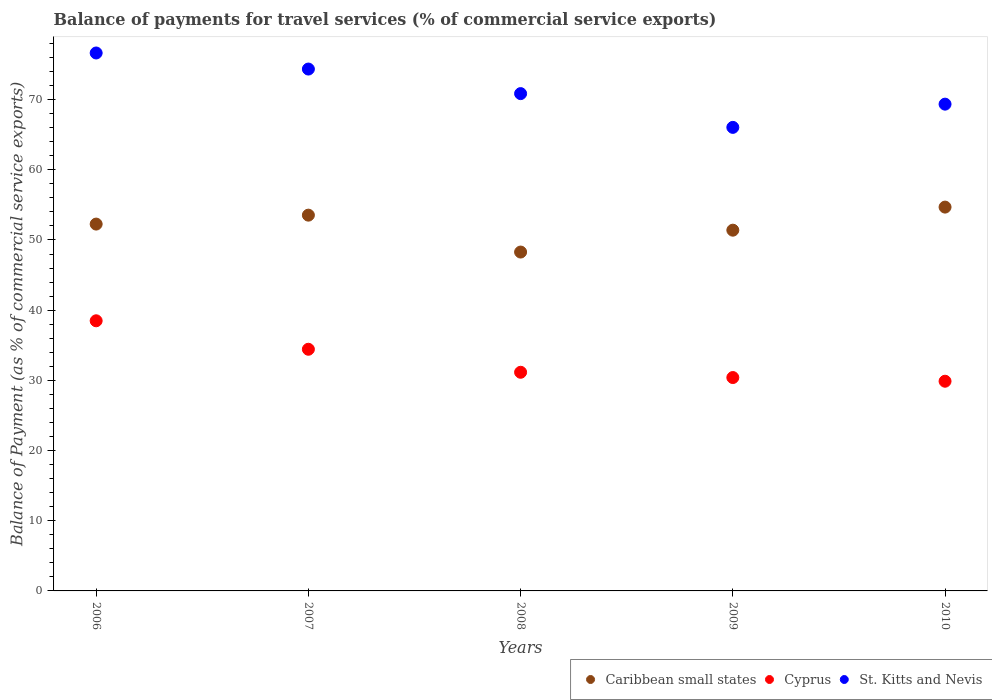What is the balance of payments for travel services in St. Kitts and Nevis in 2007?
Keep it short and to the point. 74.35. Across all years, what is the maximum balance of payments for travel services in Cyprus?
Provide a short and direct response. 38.49. Across all years, what is the minimum balance of payments for travel services in St. Kitts and Nevis?
Your answer should be very brief. 66.05. In which year was the balance of payments for travel services in Cyprus maximum?
Offer a terse response. 2006. In which year was the balance of payments for travel services in Cyprus minimum?
Keep it short and to the point. 2010. What is the total balance of payments for travel services in St. Kitts and Nevis in the graph?
Give a very brief answer. 357.26. What is the difference between the balance of payments for travel services in Cyprus in 2007 and that in 2010?
Give a very brief answer. 4.55. What is the difference between the balance of payments for travel services in Caribbean small states in 2006 and the balance of payments for travel services in Cyprus in 2010?
Your answer should be compact. 22.39. What is the average balance of payments for travel services in Caribbean small states per year?
Make the answer very short. 52.03. In the year 2010, what is the difference between the balance of payments for travel services in St. Kitts and Nevis and balance of payments for travel services in Caribbean small states?
Your answer should be very brief. 14.67. What is the ratio of the balance of payments for travel services in St. Kitts and Nevis in 2006 to that in 2010?
Your answer should be compact. 1.11. Is the balance of payments for travel services in Caribbean small states in 2006 less than that in 2009?
Give a very brief answer. No. Is the difference between the balance of payments for travel services in St. Kitts and Nevis in 2009 and 2010 greater than the difference between the balance of payments for travel services in Caribbean small states in 2009 and 2010?
Your response must be concise. No. What is the difference between the highest and the second highest balance of payments for travel services in Caribbean small states?
Ensure brevity in your answer.  1.15. What is the difference between the highest and the lowest balance of payments for travel services in St. Kitts and Nevis?
Offer a terse response. 10.6. Is the sum of the balance of payments for travel services in St. Kitts and Nevis in 2006 and 2010 greater than the maximum balance of payments for travel services in Caribbean small states across all years?
Offer a very short reply. Yes. Is it the case that in every year, the sum of the balance of payments for travel services in Cyprus and balance of payments for travel services in Caribbean small states  is greater than the balance of payments for travel services in St. Kitts and Nevis?
Your response must be concise. Yes. Is the balance of payments for travel services in Caribbean small states strictly greater than the balance of payments for travel services in Cyprus over the years?
Offer a very short reply. Yes. Is the balance of payments for travel services in Caribbean small states strictly less than the balance of payments for travel services in St. Kitts and Nevis over the years?
Keep it short and to the point. Yes. How many dotlines are there?
Your response must be concise. 3. How many years are there in the graph?
Provide a short and direct response. 5. What is the difference between two consecutive major ticks on the Y-axis?
Your response must be concise. 10. Does the graph contain any zero values?
Give a very brief answer. No. Where does the legend appear in the graph?
Your response must be concise. Bottom right. How many legend labels are there?
Offer a very short reply. 3. What is the title of the graph?
Your answer should be very brief. Balance of payments for travel services (% of commercial service exports). Does "Palau" appear as one of the legend labels in the graph?
Offer a terse response. No. What is the label or title of the Y-axis?
Your answer should be very brief. Balance of Payment (as % of commercial service exports). What is the Balance of Payment (as % of commercial service exports) in Caribbean small states in 2006?
Your response must be concise. 52.27. What is the Balance of Payment (as % of commercial service exports) in Cyprus in 2006?
Keep it short and to the point. 38.49. What is the Balance of Payment (as % of commercial service exports) in St. Kitts and Nevis in 2006?
Provide a short and direct response. 76.64. What is the Balance of Payment (as % of commercial service exports) in Caribbean small states in 2007?
Ensure brevity in your answer.  53.54. What is the Balance of Payment (as % of commercial service exports) of Cyprus in 2007?
Your response must be concise. 34.43. What is the Balance of Payment (as % of commercial service exports) of St. Kitts and Nevis in 2007?
Offer a terse response. 74.35. What is the Balance of Payment (as % of commercial service exports) of Caribbean small states in 2008?
Provide a succinct answer. 48.28. What is the Balance of Payment (as % of commercial service exports) in Cyprus in 2008?
Offer a terse response. 31.15. What is the Balance of Payment (as % of commercial service exports) in St. Kitts and Nevis in 2008?
Your response must be concise. 70.86. What is the Balance of Payment (as % of commercial service exports) in Caribbean small states in 2009?
Your response must be concise. 51.4. What is the Balance of Payment (as % of commercial service exports) in Cyprus in 2009?
Provide a short and direct response. 30.4. What is the Balance of Payment (as % of commercial service exports) in St. Kitts and Nevis in 2009?
Your response must be concise. 66.05. What is the Balance of Payment (as % of commercial service exports) of Caribbean small states in 2010?
Your answer should be very brief. 54.69. What is the Balance of Payment (as % of commercial service exports) of Cyprus in 2010?
Your answer should be very brief. 29.88. What is the Balance of Payment (as % of commercial service exports) of St. Kitts and Nevis in 2010?
Your answer should be compact. 69.36. Across all years, what is the maximum Balance of Payment (as % of commercial service exports) in Caribbean small states?
Provide a short and direct response. 54.69. Across all years, what is the maximum Balance of Payment (as % of commercial service exports) in Cyprus?
Keep it short and to the point. 38.49. Across all years, what is the maximum Balance of Payment (as % of commercial service exports) of St. Kitts and Nevis?
Your answer should be very brief. 76.64. Across all years, what is the minimum Balance of Payment (as % of commercial service exports) in Caribbean small states?
Keep it short and to the point. 48.28. Across all years, what is the minimum Balance of Payment (as % of commercial service exports) in Cyprus?
Your response must be concise. 29.88. Across all years, what is the minimum Balance of Payment (as % of commercial service exports) of St. Kitts and Nevis?
Ensure brevity in your answer.  66.05. What is the total Balance of Payment (as % of commercial service exports) of Caribbean small states in the graph?
Keep it short and to the point. 260.17. What is the total Balance of Payment (as % of commercial service exports) in Cyprus in the graph?
Provide a succinct answer. 164.35. What is the total Balance of Payment (as % of commercial service exports) of St. Kitts and Nevis in the graph?
Ensure brevity in your answer.  357.26. What is the difference between the Balance of Payment (as % of commercial service exports) in Caribbean small states in 2006 and that in 2007?
Ensure brevity in your answer.  -1.27. What is the difference between the Balance of Payment (as % of commercial service exports) of Cyprus in 2006 and that in 2007?
Ensure brevity in your answer.  4.06. What is the difference between the Balance of Payment (as % of commercial service exports) in St. Kitts and Nevis in 2006 and that in 2007?
Ensure brevity in your answer.  2.29. What is the difference between the Balance of Payment (as % of commercial service exports) in Caribbean small states in 2006 and that in 2008?
Provide a succinct answer. 3.98. What is the difference between the Balance of Payment (as % of commercial service exports) in Cyprus in 2006 and that in 2008?
Offer a terse response. 7.34. What is the difference between the Balance of Payment (as % of commercial service exports) in St. Kitts and Nevis in 2006 and that in 2008?
Ensure brevity in your answer.  5.79. What is the difference between the Balance of Payment (as % of commercial service exports) of Caribbean small states in 2006 and that in 2009?
Provide a succinct answer. 0.87. What is the difference between the Balance of Payment (as % of commercial service exports) in Cyprus in 2006 and that in 2009?
Your answer should be very brief. 8.09. What is the difference between the Balance of Payment (as % of commercial service exports) in St. Kitts and Nevis in 2006 and that in 2009?
Offer a very short reply. 10.6. What is the difference between the Balance of Payment (as % of commercial service exports) in Caribbean small states in 2006 and that in 2010?
Offer a terse response. -2.42. What is the difference between the Balance of Payment (as % of commercial service exports) of Cyprus in 2006 and that in 2010?
Offer a very short reply. 8.61. What is the difference between the Balance of Payment (as % of commercial service exports) of St. Kitts and Nevis in 2006 and that in 2010?
Provide a short and direct response. 7.29. What is the difference between the Balance of Payment (as % of commercial service exports) in Caribbean small states in 2007 and that in 2008?
Ensure brevity in your answer.  5.26. What is the difference between the Balance of Payment (as % of commercial service exports) in Cyprus in 2007 and that in 2008?
Ensure brevity in your answer.  3.28. What is the difference between the Balance of Payment (as % of commercial service exports) in St. Kitts and Nevis in 2007 and that in 2008?
Offer a very short reply. 3.5. What is the difference between the Balance of Payment (as % of commercial service exports) of Caribbean small states in 2007 and that in 2009?
Offer a terse response. 2.14. What is the difference between the Balance of Payment (as % of commercial service exports) of Cyprus in 2007 and that in 2009?
Your response must be concise. 4.03. What is the difference between the Balance of Payment (as % of commercial service exports) in St. Kitts and Nevis in 2007 and that in 2009?
Offer a terse response. 8.31. What is the difference between the Balance of Payment (as % of commercial service exports) in Caribbean small states in 2007 and that in 2010?
Give a very brief answer. -1.15. What is the difference between the Balance of Payment (as % of commercial service exports) in Cyprus in 2007 and that in 2010?
Your response must be concise. 4.55. What is the difference between the Balance of Payment (as % of commercial service exports) in St. Kitts and Nevis in 2007 and that in 2010?
Provide a short and direct response. 5. What is the difference between the Balance of Payment (as % of commercial service exports) in Caribbean small states in 2008 and that in 2009?
Make the answer very short. -3.12. What is the difference between the Balance of Payment (as % of commercial service exports) in Cyprus in 2008 and that in 2009?
Provide a short and direct response. 0.75. What is the difference between the Balance of Payment (as % of commercial service exports) of St. Kitts and Nevis in 2008 and that in 2009?
Provide a short and direct response. 4.81. What is the difference between the Balance of Payment (as % of commercial service exports) in Caribbean small states in 2008 and that in 2010?
Make the answer very short. -6.4. What is the difference between the Balance of Payment (as % of commercial service exports) in Cyprus in 2008 and that in 2010?
Give a very brief answer. 1.28. What is the difference between the Balance of Payment (as % of commercial service exports) of St. Kitts and Nevis in 2008 and that in 2010?
Offer a terse response. 1.5. What is the difference between the Balance of Payment (as % of commercial service exports) of Caribbean small states in 2009 and that in 2010?
Make the answer very short. -3.29. What is the difference between the Balance of Payment (as % of commercial service exports) in Cyprus in 2009 and that in 2010?
Your answer should be very brief. 0.52. What is the difference between the Balance of Payment (as % of commercial service exports) of St. Kitts and Nevis in 2009 and that in 2010?
Give a very brief answer. -3.31. What is the difference between the Balance of Payment (as % of commercial service exports) in Caribbean small states in 2006 and the Balance of Payment (as % of commercial service exports) in Cyprus in 2007?
Make the answer very short. 17.84. What is the difference between the Balance of Payment (as % of commercial service exports) in Caribbean small states in 2006 and the Balance of Payment (as % of commercial service exports) in St. Kitts and Nevis in 2007?
Offer a terse response. -22.09. What is the difference between the Balance of Payment (as % of commercial service exports) in Cyprus in 2006 and the Balance of Payment (as % of commercial service exports) in St. Kitts and Nevis in 2007?
Offer a very short reply. -35.87. What is the difference between the Balance of Payment (as % of commercial service exports) of Caribbean small states in 2006 and the Balance of Payment (as % of commercial service exports) of Cyprus in 2008?
Make the answer very short. 21.11. What is the difference between the Balance of Payment (as % of commercial service exports) of Caribbean small states in 2006 and the Balance of Payment (as % of commercial service exports) of St. Kitts and Nevis in 2008?
Ensure brevity in your answer.  -18.59. What is the difference between the Balance of Payment (as % of commercial service exports) of Cyprus in 2006 and the Balance of Payment (as % of commercial service exports) of St. Kitts and Nevis in 2008?
Give a very brief answer. -32.37. What is the difference between the Balance of Payment (as % of commercial service exports) in Caribbean small states in 2006 and the Balance of Payment (as % of commercial service exports) in Cyprus in 2009?
Offer a terse response. 21.87. What is the difference between the Balance of Payment (as % of commercial service exports) in Caribbean small states in 2006 and the Balance of Payment (as % of commercial service exports) in St. Kitts and Nevis in 2009?
Your answer should be compact. -13.78. What is the difference between the Balance of Payment (as % of commercial service exports) in Cyprus in 2006 and the Balance of Payment (as % of commercial service exports) in St. Kitts and Nevis in 2009?
Offer a terse response. -27.56. What is the difference between the Balance of Payment (as % of commercial service exports) in Caribbean small states in 2006 and the Balance of Payment (as % of commercial service exports) in Cyprus in 2010?
Your answer should be very brief. 22.39. What is the difference between the Balance of Payment (as % of commercial service exports) in Caribbean small states in 2006 and the Balance of Payment (as % of commercial service exports) in St. Kitts and Nevis in 2010?
Ensure brevity in your answer.  -17.09. What is the difference between the Balance of Payment (as % of commercial service exports) in Cyprus in 2006 and the Balance of Payment (as % of commercial service exports) in St. Kitts and Nevis in 2010?
Offer a very short reply. -30.87. What is the difference between the Balance of Payment (as % of commercial service exports) in Caribbean small states in 2007 and the Balance of Payment (as % of commercial service exports) in Cyprus in 2008?
Ensure brevity in your answer.  22.39. What is the difference between the Balance of Payment (as % of commercial service exports) in Caribbean small states in 2007 and the Balance of Payment (as % of commercial service exports) in St. Kitts and Nevis in 2008?
Offer a very short reply. -17.32. What is the difference between the Balance of Payment (as % of commercial service exports) in Cyprus in 2007 and the Balance of Payment (as % of commercial service exports) in St. Kitts and Nevis in 2008?
Offer a very short reply. -36.42. What is the difference between the Balance of Payment (as % of commercial service exports) of Caribbean small states in 2007 and the Balance of Payment (as % of commercial service exports) of Cyprus in 2009?
Keep it short and to the point. 23.14. What is the difference between the Balance of Payment (as % of commercial service exports) in Caribbean small states in 2007 and the Balance of Payment (as % of commercial service exports) in St. Kitts and Nevis in 2009?
Offer a very short reply. -12.51. What is the difference between the Balance of Payment (as % of commercial service exports) of Cyprus in 2007 and the Balance of Payment (as % of commercial service exports) of St. Kitts and Nevis in 2009?
Make the answer very short. -31.61. What is the difference between the Balance of Payment (as % of commercial service exports) in Caribbean small states in 2007 and the Balance of Payment (as % of commercial service exports) in Cyprus in 2010?
Offer a terse response. 23.66. What is the difference between the Balance of Payment (as % of commercial service exports) of Caribbean small states in 2007 and the Balance of Payment (as % of commercial service exports) of St. Kitts and Nevis in 2010?
Offer a terse response. -15.82. What is the difference between the Balance of Payment (as % of commercial service exports) of Cyprus in 2007 and the Balance of Payment (as % of commercial service exports) of St. Kitts and Nevis in 2010?
Provide a succinct answer. -34.92. What is the difference between the Balance of Payment (as % of commercial service exports) of Caribbean small states in 2008 and the Balance of Payment (as % of commercial service exports) of Cyprus in 2009?
Make the answer very short. 17.88. What is the difference between the Balance of Payment (as % of commercial service exports) in Caribbean small states in 2008 and the Balance of Payment (as % of commercial service exports) in St. Kitts and Nevis in 2009?
Provide a succinct answer. -17.76. What is the difference between the Balance of Payment (as % of commercial service exports) in Cyprus in 2008 and the Balance of Payment (as % of commercial service exports) in St. Kitts and Nevis in 2009?
Your answer should be very brief. -34.89. What is the difference between the Balance of Payment (as % of commercial service exports) of Caribbean small states in 2008 and the Balance of Payment (as % of commercial service exports) of Cyprus in 2010?
Your response must be concise. 18.41. What is the difference between the Balance of Payment (as % of commercial service exports) in Caribbean small states in 2008 and the Balance of Payment (as % of commercial service exports) in St. Kitts and Nevis in 2010?
Your response must be concise. -21.07. What is the difference between the Balance of Payment (as % of commercial service exports) of Cyprus in 2008 and the Balance of Payment (as % of commercial service exports) of St. Kitts and Nevis in 2010?
Offer a terse response. -38.2. What is the difference between the Balance of Payment (as % of commercial service exports) in Caribbean small states in 2009 and the Balance of Payment (as % of commercial service exports) in Cyprus in 2010?
Ensure brevity in your answer.  21.52. What is the difference between the Balance of Payment (as % of commercial service exports) of Caribbean small states in 2009 and the Balance of Payment (as % of commercial service exports) of St. Kitts and Nevis in 2010?
Offer a very short reply. -17.96. What is the difference between the Balance of Payment (as % of commercial service exports) of Cyprus in 2009 and the Balance of Payment (as % of commercial service exports) of St. Kitts and Nevis in 2010?
Offer a terse response. -38.95. What is the average Balance of Payment (as % of commercial service exports) in Caribbean small states per year?
Ensure brevity in your answer.  52.03. What is the average Balance of Payment (as % of commercial service exports) in Cyprus per year?
Your answer should be compact. 32.87. What is the average Balance of Payment (as % of commercial service exports) of St. Kitts and Nevis per year?
Ensure brevity in your answer.  71.45. In the year 2006, what is the difference between the Balance of Payment (as % of commercial service exports) in Caribbean small states and Balance of Payment (as % of commercial service exports) in Cyprus?
Your response must be concise. 13.78. In the year 2006, what is the difference between the Balance of Payment (as % of commercial service exports) of Caribbean small states and Balance of Payment (as % of commercial service exports) of St. Kitts and Nevis?
Make the answer very short. -24.38. In the year 2006, what is the difference between the Balance of Payment (as % of commercial service exports) in Cyprus and Balance of Payment (as % of commercial service exports) in St. Kitts and Nevis?
Provide a short and direct response. -38.16. In the year 2007, what is the difference between the Balance of Payment (as % of commercial service exports) in Caribbean small states and Balance of Payment (as % of commercial service exports) in Cyprus?
Your answer should be very brief. 19.11. In the year 2007, what is the difference between the Balance of Payment (as % of commercial service exports) in Caribbean small states and Balance of Payment (as % of commercial service exports) in St. Kitts and Nevis?
Keep it short and to the point. -20.82. In the year 2007, what is the difference between the Balance of Payment (as % of commercial service exports) of Cyprus and Balance of Payment (as % of commercial service exports) of St. Kitts and Nevis?
Offer a terse response. -39.92. In the year 2008, what is the difference between the Balance of Payment (as % of commercial service exports) of Caribbean small states and Balance of Payment (as % of commercial service exports) of Cyprus?
Give a very brief answer. 17.13. In the year 2008, what is the difference between the Balance of Payment (as % of commercial service exports) in Caribbean small states and Balance of Payment (as % of commercial service exports) in St. Kitts and Nevis?
Provide a succinct answer. -22.57. In the year 2008, what is the difference between the Balance of Payment (as % of commercial service exports) in Cyprus and Balance of Payment (as % of commercial service exports) in St. Kitts and Nevis?
Make the answer very short. -39.7. In the year 2009, what is the difference between the Balance of Payment (as % of commercial service exports) of Caribbean small states and Balance of Payment (as % of commercial service exports) of Cyprus?
Offer a terse response. 21. In the year 2009, what is the difference between the Balance of Payment (as % of commercial service exports) of Caribbean small states and Balance of Payment (as % of commercial service exports) of St. Kitts and Nevis?
Provide a succinct answer. -14.65. In the year 2009, what is the difference between the Balance of Payment (as % of commercial service exports) in Cyprus and Balance of Payment (as % of commercial service exports) in St. Kitts and Nevis?
Your response must be concise. -35.64. In the year 2010, what is the difference between the Balance of Payment (as % of commercial service exports) in Caribbean small states and Balance of Payment (as % of commercial service exports) in Cyprus?
Keep it short and to the point. 24.81. In the year 2010, what is the difference between the Balance of Payment (as % of commercial service exports) of Caribbean small states and Balance of Payment (as % of commercial service exports) of St. Kitts and Nevis?
Offer a very short reply. -14.67. In the year 2010, what is the difference between the Balance of Payment (as % of commercial service exports) in Cyprus and Balance of Payment (as % of commercial service exports) in St. Kitts and Nevis?
Your answer should be very brief. -39.48. What is the ratio of the Balance of Payment (as % of commercial service exports) of Caribbean small states in 2006 to that in 2007?
Ensure brevity in your answer.  0.98. What is the ratio of the Balance of Payment (as % of commercial service exports) in Cyprus in 2006 to that in 2007?
Ensure brevity in your answer.  1.12. What is the ratio of the Balance of Payment (as % of commercial service exports) in St. Kitts and Nevis in 2006 to that in 2007?
Provide a short and direct response. 1.03. What is the ratio of the Balance of Payment (as % of commercial service exports) of Caribbean small states in 2006 to that in 2008?
Offer a terse response. 1.08. What is the ratio of the Balance of Payment (as % of commercial service exports) in Cyprus in 2006 to that in 2008?
Your response must be concise. 1.24. What is the ratio of the Balance of Payment (as % of commercial service exports) of St. Kitts and Nevis in 2006 to that in 2008?
Your answer should be compact. 1.08. What is the ratio of the Balance of Payment (as % of commercial service exports) in Caribbean small states in 2006 to that in 2009?
Your answer should be very brief. 1.02. What is the ratio of the Balance of Payment (as % of commercial service exports) of Cyprus in 2006 to that in 2009?
Offer a terse response. 1.27. What is the ratio of the Balance of Payment (as % of commercial service exports) in St. Kitts and Nevis in 2006 to that in 2009?
Your answer should be compact. 1.16. What is the ratio of the Balance of Payment (as % of commercial service exports) of Caribbean small states in 2006 to that in 2010?
Give a very brief answer. 0.96. What is the ratio of the Balance of Payment (as % of commercial service exports) of Cyprus in 2006 to that in 2010?
Provide a short and direct response. 1.29. What is the ratio of the Balance of Payment (as % of commercial service exports) of St. Kitts and Nevis in 2006 to that in 2010?
Provide a succinct answer. 1.11. What is the ratio of the Balance of Payment (as % of commercial service exports) of Caribbean small states in 2007 to that in 2008?
Make the answer very short. 1.11. What is the ratio of the Balance of Payment (as % of commercial service exports) in Cyprus in 2007 to that in 2008?
Provide a short and direct response. 1.11. What is the ratio of the Balance of Payment (as % of commercial service exports) of St. Kitts and Nevis in 2007 to that in 2008?
Keep it short and to the point. 1.05. What is the ratio of the Balance of Payment (as % of commercial service exports) of Caribbean small states in 2007 to that in 2009?
Make the answer very short. 1.04. What is the ratio of the Balance of Payment (as % of commercial service exports) of Cyprus in 2007 to that in 2009?
Offer a very short reply. 1.13. What is the ratio of the Balance of Payment (as % of commercial service exports) in St. Kitts and Nevis in 2007 to that in 2009?
Provide a succinct answer. 1.13. What is the ratio of the Balance of Payment (as % of commercial service exports) in Cyprus in 2007 to that in 2010?
Your answer should be very brief. 1.15. What is the ratio of the Balance of Payment (as % of commercial service exports) in St. Kitts and Nevis in 2007 to that in 2010?
Keep it short and to the point. 1.07. What is the ratio of the Balance of Payment (as % of commercial service exports) in Caribbean small states in 2008 to that in 2009?
Give a very brief answer. 0.94. What is the ratio of the Balance of Payment (as % of commercial service exports) in Cyprus in 2008 to that in 2009?
Ensure brevity in your answer.  1.02. What is the ratio of the Balance of Payment (as % of commercial service exports) of St. Kitts and Nevis in 2008 to that in 2009?
Your answer should be compact. 1.07. What is the ratio of the Balance of Payment (as % of commercial service exports) of Caribbean small states in 2008 to that in 2010?
Your response must be concise. 0.88. What is the ratio of the Balance of Payment (as % of commercial service exports) of Cyprus in 2008 to that in 2010?
Your answer should be compact. 1.04. What is the ratio of the Balance of Payment (as % of commercial service exports) in St. Kitts and Nevis in 2008 to that in 2010?
Provide a short and direct response. 1.02. What is the ratio of the Balance of Payment (as % of commercial service exports) in Caribbean small states in 2009 to that in 2010?
Offer a terse response. 0.94. What is the ratio of the Balance of Payment (as % of commercial service exports) of Cyprus in 2009 to that in 2010?
Your response must be concise. 1.02. What is the ratio of the Balance of Payment (as % of commercial service exports) of St. Kitts and Nevis in 2009 to that in 2010?
Offer a terse response. 0.95. What is the difference between the highest and the second highest Balance of Payment (as % of commercial service exports) in Caribbean small states?
Ensure brevity in your answer.  1.15. What is the difference between the highest and the second highest Balance of Payment (as % of commercial service exports) of Cyprus?
Keep it short and to the point. 4.06. What is the difference between the highest and the second highest Balance of Payment (as % of commercial service exports) in St. Kitts and Nevis?
Your response must be concise. 2.29. What is the difference between the highest and the lowest Balance of Payment (as % of commercial service exports) in Caribbean small states?
Make the answer very short. 6.4. What is the difference between the highest and the lowest Balance of Payment (as % of commercial service exports) in Cyprus?
Keep it short and to the point. 8.61. What is the difference between the highest and the lowest Balance of Payment (as % of commercial service exports) in St. Kitts and Nevis?
Make the answer very short. 10.6. 